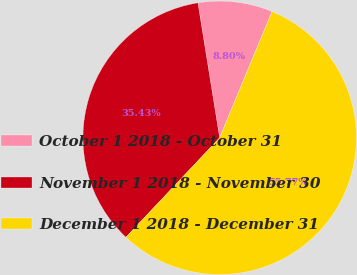Convert chart to OTSL. <chart><loc_0><loc_0><loc_500><loc_500><pie_chart><fcel>October 1 2018 - October 31<fcel>November 1 2018 - November 30<fcel>December 1 2018 - December 31<nl><fcel>8.8%<fcel>35.43%<fcel>55.77%<nl></chart> 